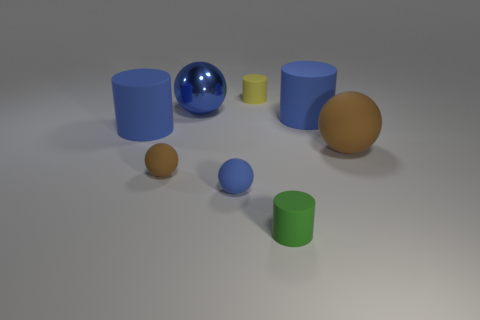There is a brown sphere that is on the right side of the big metallic sphere; what is its material?
Offer a very short reply. Rubber. Does the metallic thing have the same size as the green thing?
Your answer should be compact. No. Is the number of big blue spheres to the left of the small brown object greater than the number of big red matte things?
Your answer should be very brief. No. What size is the blue ball that is made of the same material as the yellow cylinder?
Keep it short and to the point. Small. There is a tiny brown thing; are there any tiny green objects behind it?
Give a very brief answer. No. Do the small yellow thing and the tiny green object have the same shape?
Provide a short and direct response. Yes. There is a cylinder in front of the cylinder that is left of the brown matte ball to the left of the big rubber sphere; how big is it?
Provide a short and direct response. Small. What is the tiny blue object made of?
Make the answer very short. Rubber. What is the size of the rubber ball that is the same color as the metallic object?
Keep it short and to the point. Small. Does the big brown rubber object have the same shape as the big blue matte thing that is on the right side of the green cylinder?
Your response must be concise. No. 